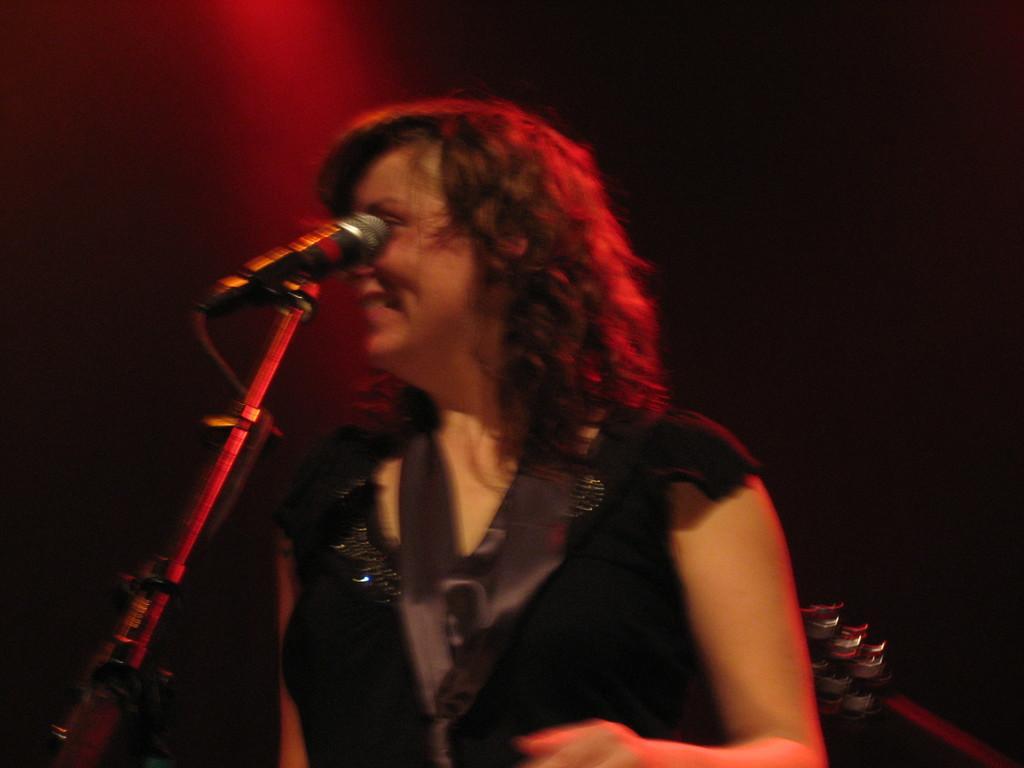Can you describe this image briefly? In the picture we can see a woman standing near the microphone and smiling, she is with the black color dress and on her we can see a red color light focus. 